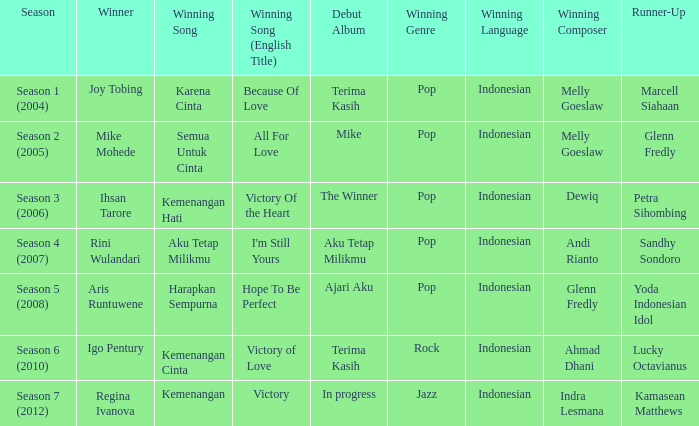Who won with the song kemenangan cinta? Igo Pentury. 